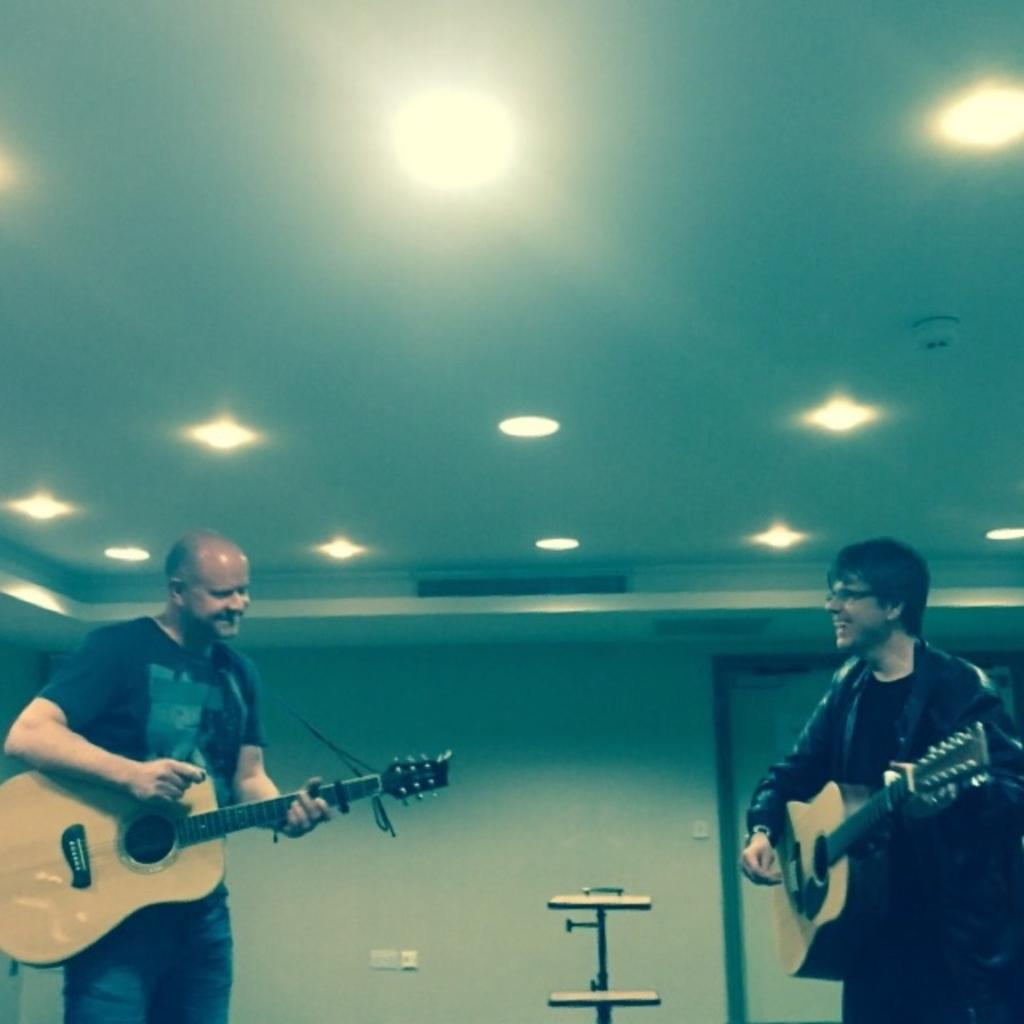How many people are in the image? There are two persons in the image. What are the two persons doing in the image? The two persons are holding a guitar and singing. What type of kettle is visible in the image? There is no kettle present in the image. Are the two persons driving a vehicle in the image? No, the two persons are not driving a vehicle in the image; they are holding a guitar and singing. 